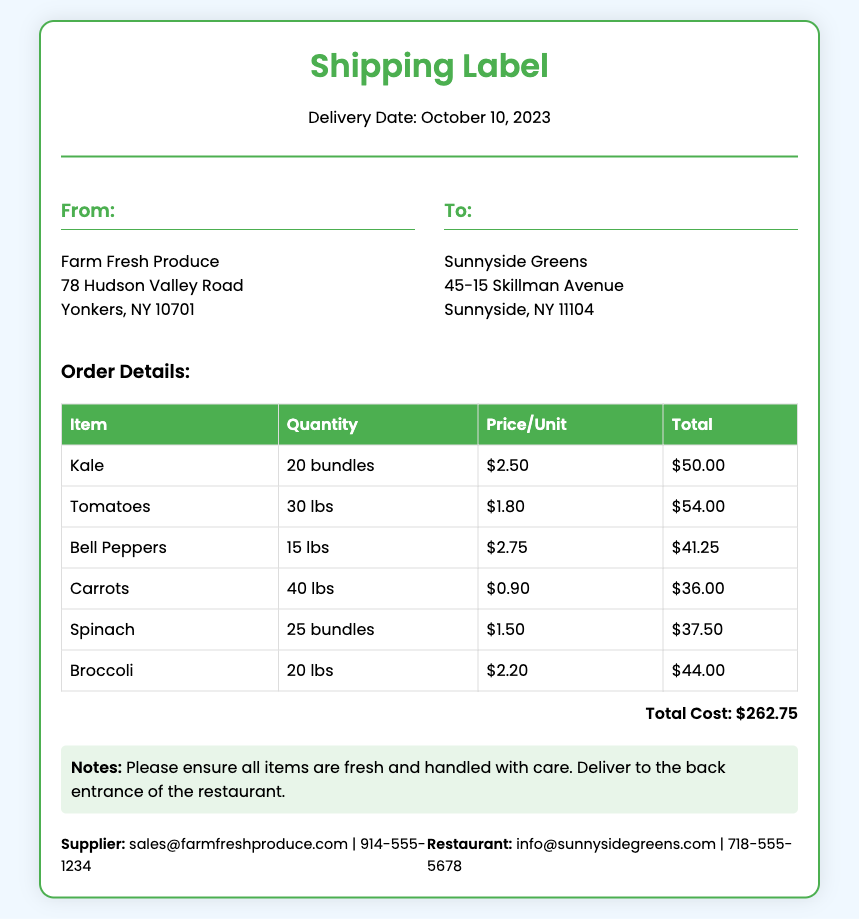What is the delivery date? The delivery date is listed prominently at the top of the document.
Answer: October 10, 2023 Who is the supplier? The supplier's name is mentioned in the "From" section of the document.
Answer: Farm Fresh Produce How many bundles of kale are ordered? The quantity of kale is specified in the order details table.
Answer: 20 bundles What is the total cost of the order? The total cost is highlighted in the "total" section of the document.
Answer: $262.75 Which vegetable has the highest unit price? The unit prices of the vegetables are included in the order details.
Answer: Bell Peppers Where should the delivery be made? The delivery instructions are specified in the notes section of the document.
Answer: Back entrance of the restaurant What is the price per unit for tomatoes? The price per unit for tomatoes is listed in the order details table.
Answer: $1.80 How many pounds of carrots are ordered? The order details provide the specific quantity for carrots.
Answer: 40 lbs 